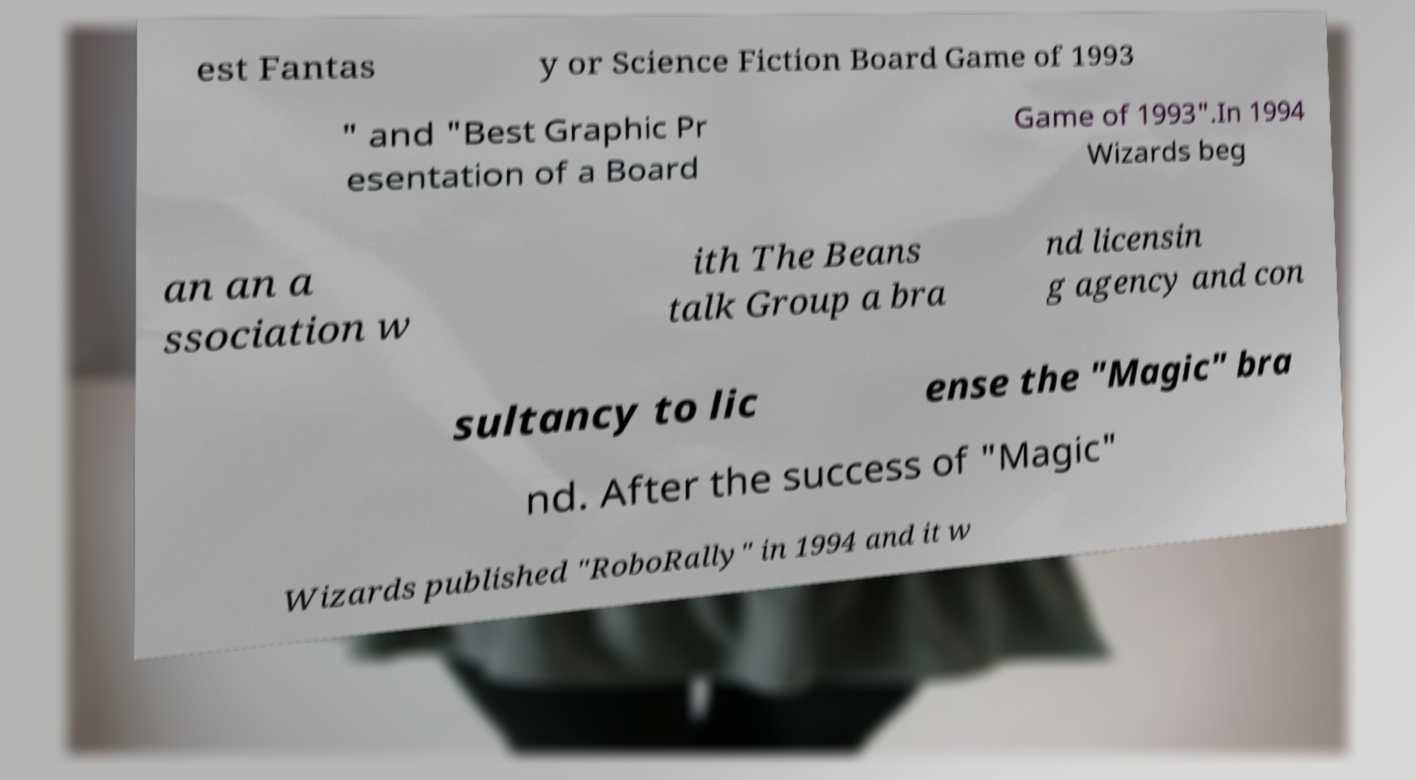Please identify and transcribe the text found in this image. est Fantas y or Science Fiction Board Game of 1993 " and "Best Graphic Pr esentation of a Board Game of 1993".In 1994 Wizards beg an an a ssociation w ith The Beans talk Group a bra nd licensin g agency and con sultancy to lic ense the "Magic" bra nd. After the success of "Magic" Wizards published "RoboRally" in 1994 and it w 